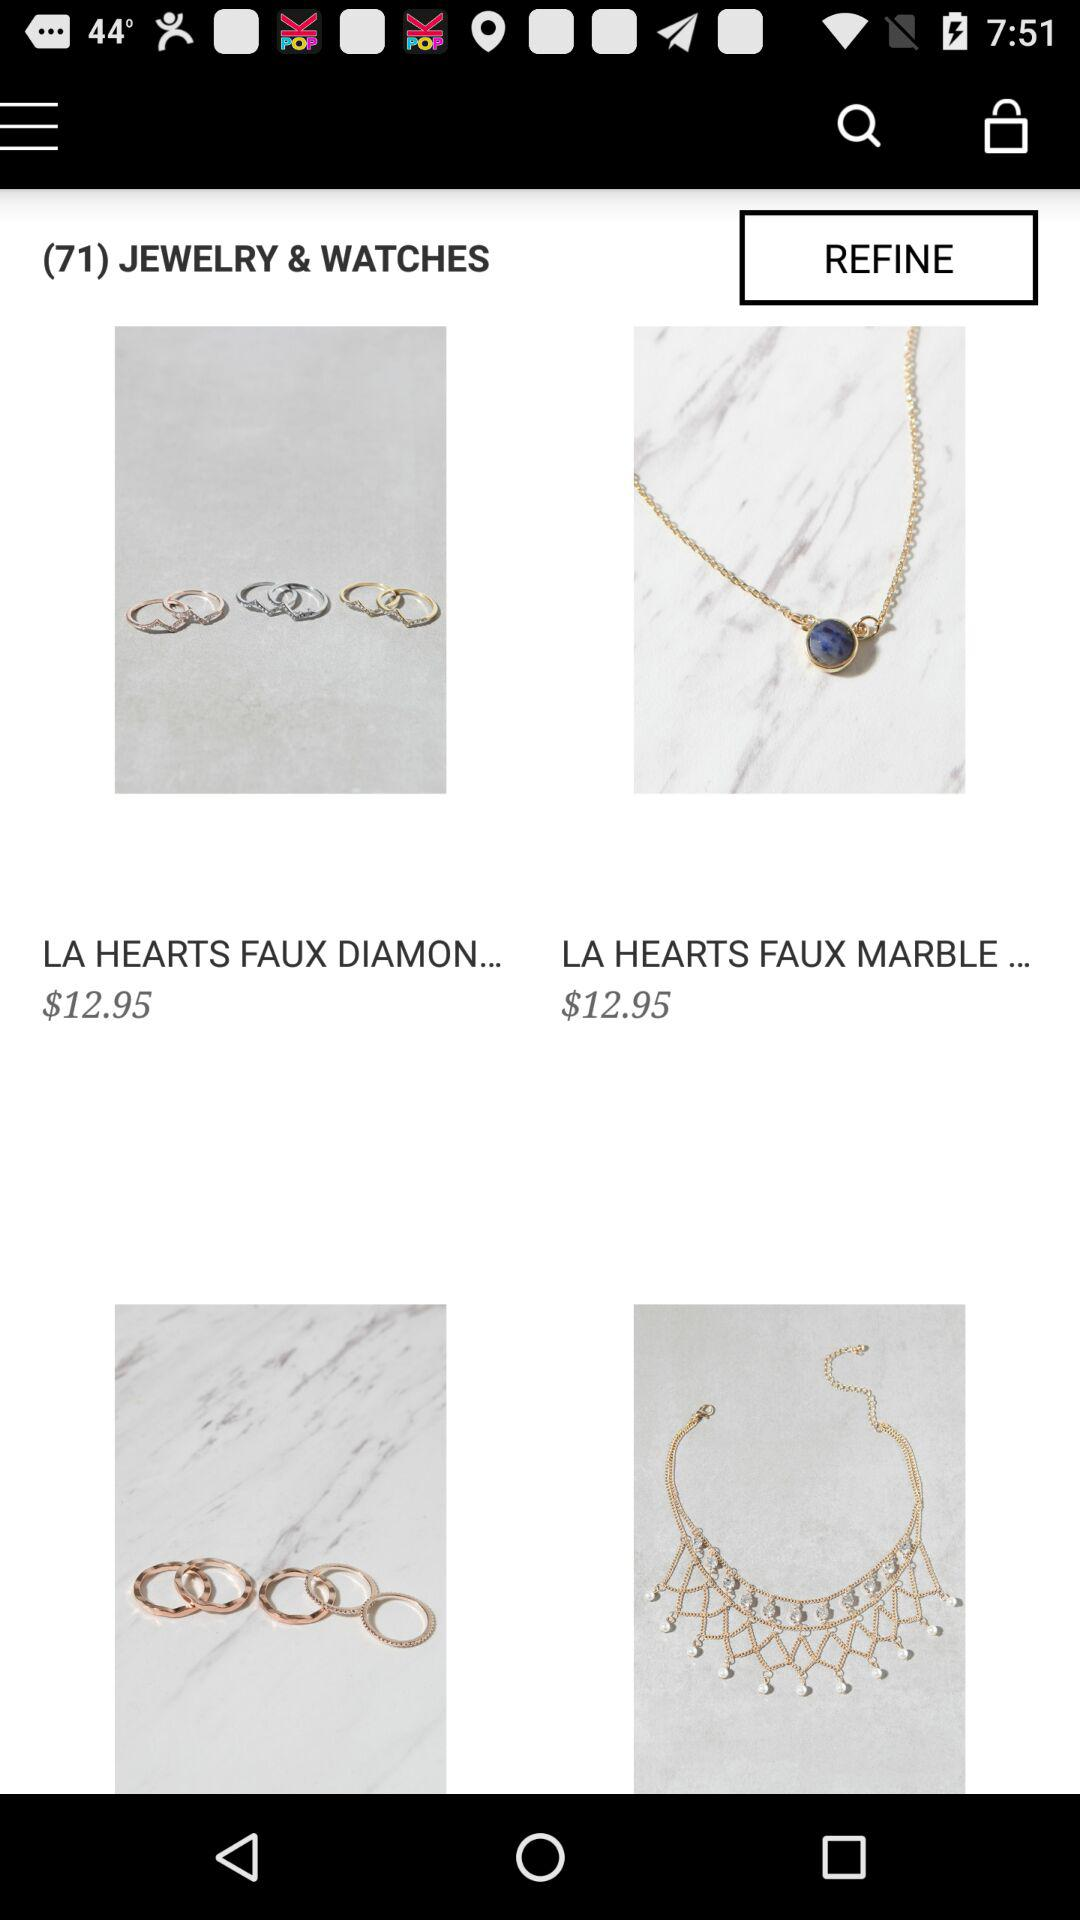What is the number of the jewelry & watches? The number of the jewelry & watches is 71. 